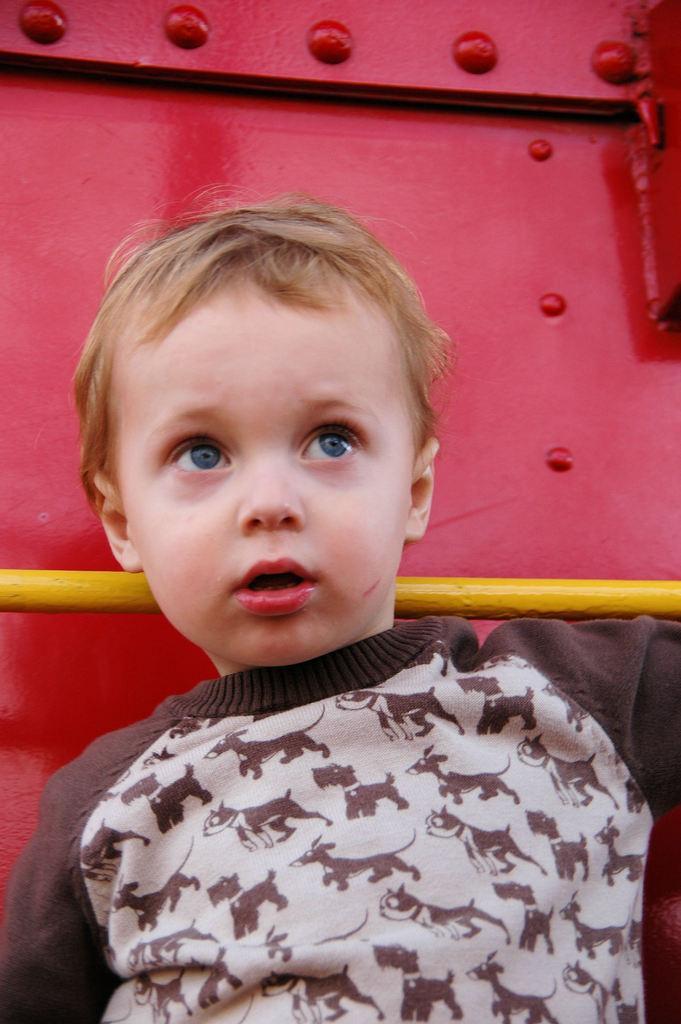How would you summarize this image in a sentence or two? In this image I can see there is a small boy, standing and there is a red colored metal in the backdrop. 